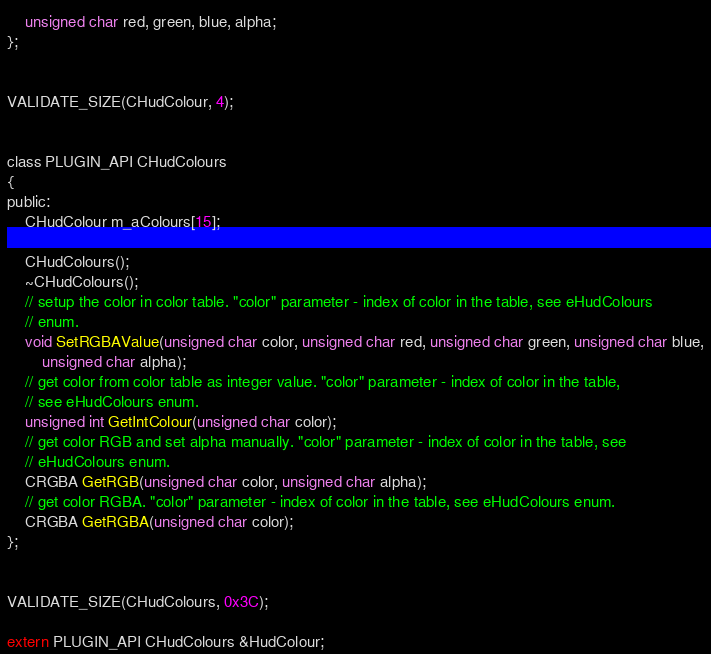<code> <loc_0><loc_0><loc_500><loc_500><_C_>	unsigned char red, green, blue, alpha;
};


VALIDATE_SIZE(CHudColour, 4);


class PLUGIN_API CHudColours
{
public:
	CHudColour m_aColours[15];

	CHudColours();
	~CHudColours();
	// setup the color in color table. "color" parameter - index of color in the table, see eHudColours 
	// enum.
	void SetRGBAValue(unsigned char color, unsigned char red, unsigned char green, unsigned char blue,
		unsigned char alpha);
	// get color from color table as integer value. "color" parameter - index of color in the table, 
	// see eHudColours enum.
	unsigned int GetIntColour(unsigned char color);
	// get color RGB and set alpha manually. "color" parameter - index of color in the table, see 
	// eHudColours enum.
	CRGBA GetRGB(unsigned char color, unsigned char alpha);
	// get color RGBA. "color" parameter - index of color in the table, see eHudColours enum.
	CRGBA GetRGBA(unsigned char color);
};


VALIDATE_SIZE(CHudColours, 0x3C);

extern PLUGIN_API CHudColours &HudColour;</code> 